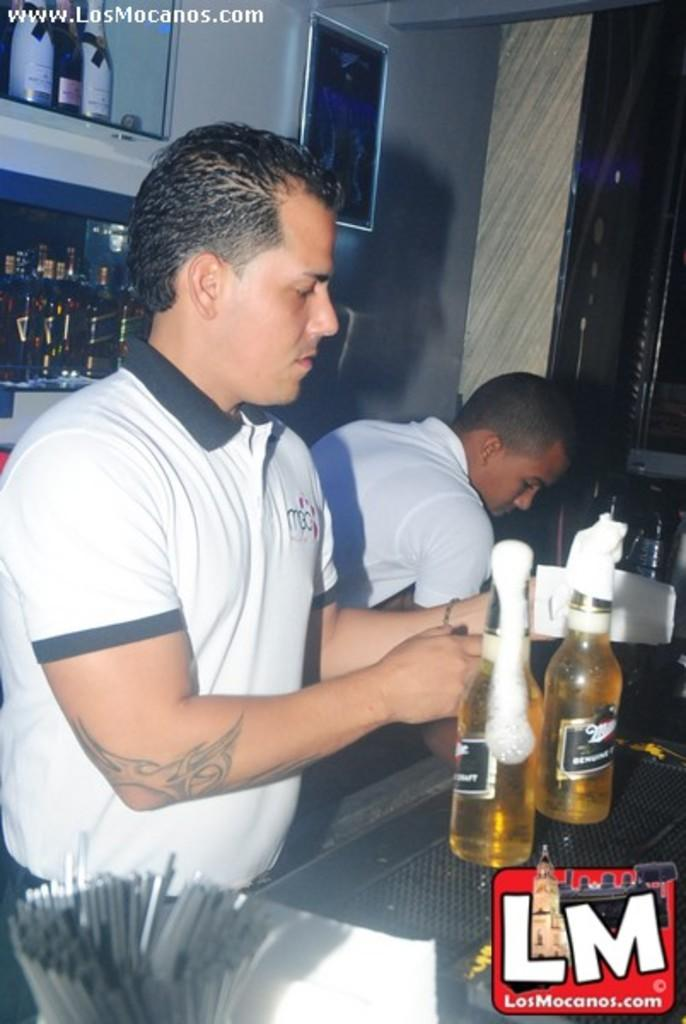How many people are in the image? There are two persons in the middle of the image. What is present in the image besides the people? There is a table in the image. What can be seen on the table? There are bottles on the table. What can be seen in the background of the image? There is a wall and a frame in the background of the image. What type of glove is hanging from the wall in the image? There is no glove present in the image; only a table, bottles, wall, and frame are visible. 